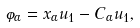<formula> <loc_0><loc_0><loc_500><loc_500>\varphi _ { \alpha } = x _ { \alpha } u _ { 1 } - C _ { \alpha } u _ { 1 } ,</formula> 